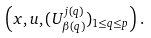<formula> <loc_0><loc_0><loc_500><loc_500>\left ( x , u , ( U _ { \beta ( q ) } ^ { j ( q ) } ) _ { 1 \leq q \leq p } \right ) .</formula> 